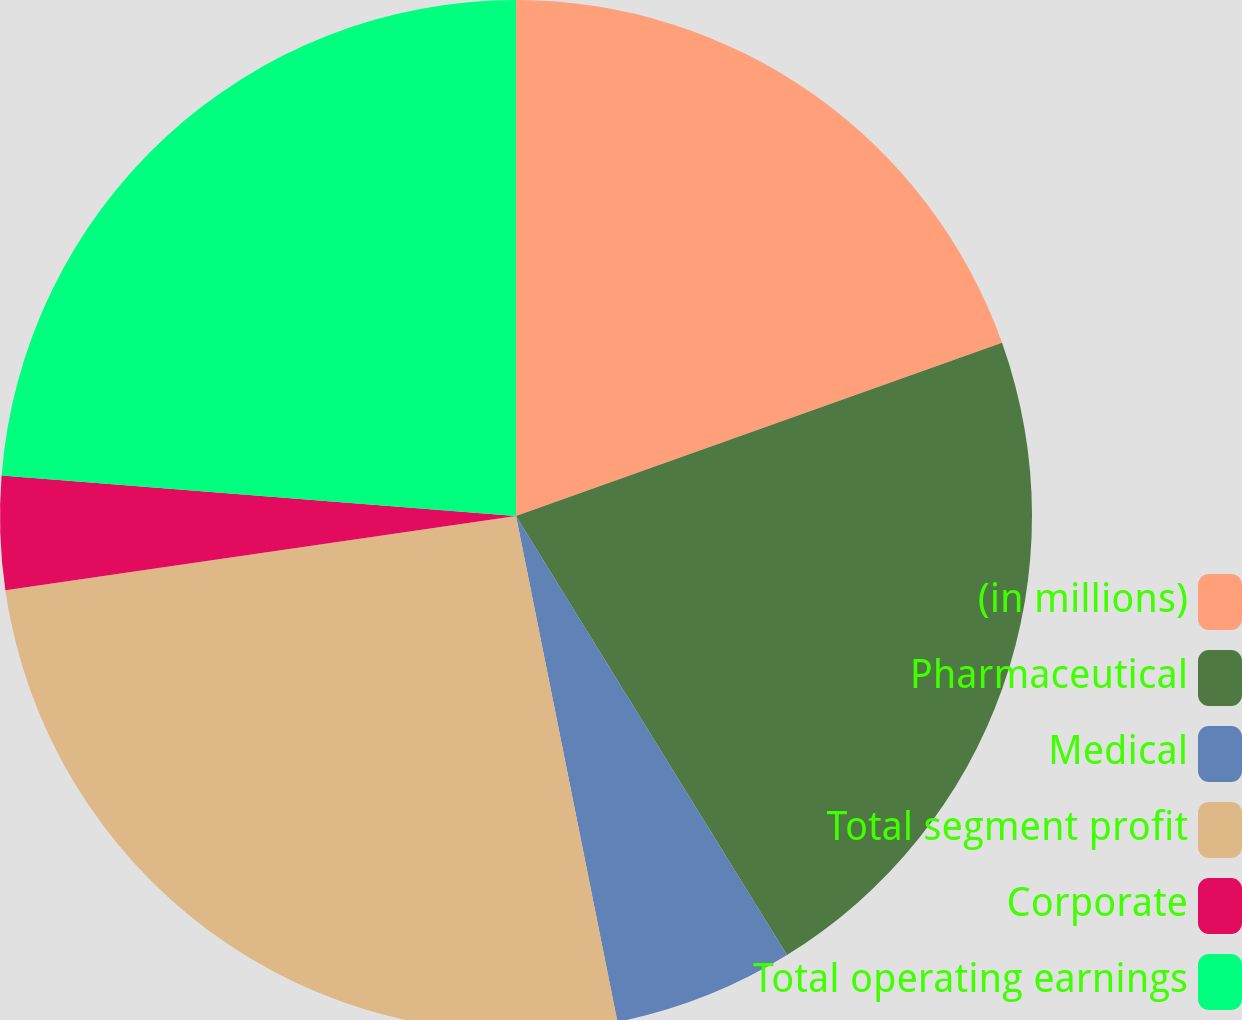<chart> <loc_0><loc_0><loc_500><loc_500><pie_chart><fcel>(in millions)<fcel>Pharmaceutical<fcel>Medical<fcel>Total segment profit<fcel>Corporate<fcel>Total operating earnings<nl><fcel>19.55%<fcel>21.65%<fcel>5.65%<fcel>25.85%<fcel>3.55%<fcel>23.75%<nl></chart> 